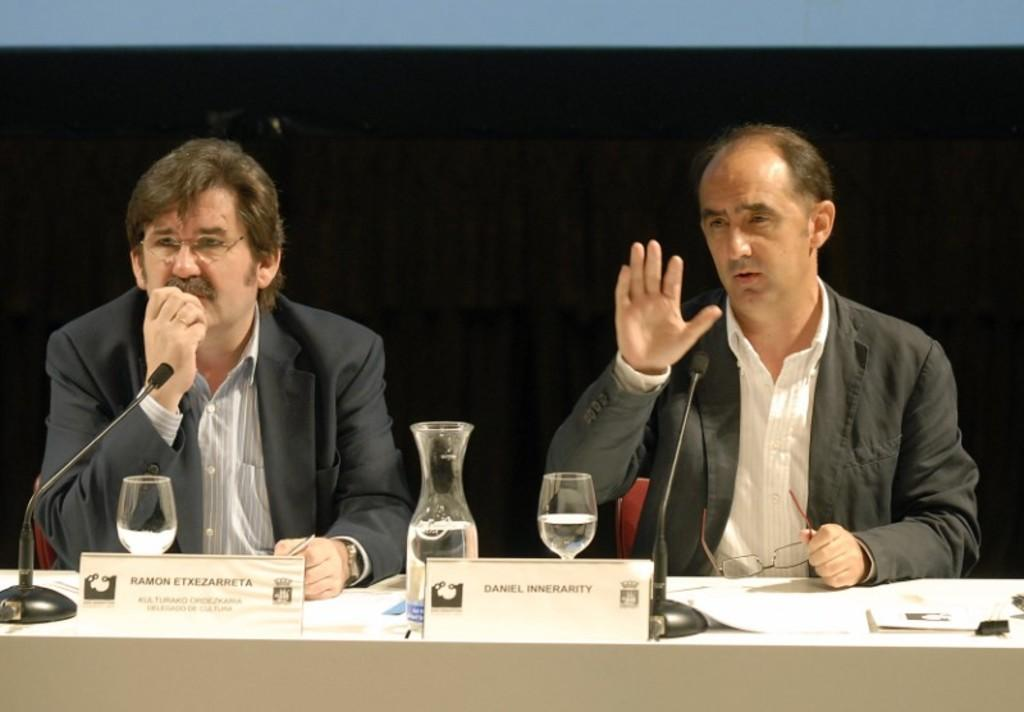How many men are sitting in the image? There are two men sitting in the image. What is present on the table in the image? There is a table in the image with name boards, a water jug, wine glasses, microphones, and files on it. What can be inferred about the setting from the background of the image? The background of the image appears dark, which might suggest a dimly lit or indoor setting. How many geese are present in the image? There are no geese present in the image. What type of land can be seen in the background of the image? There is no land visible in the image, as the background appears dark. 